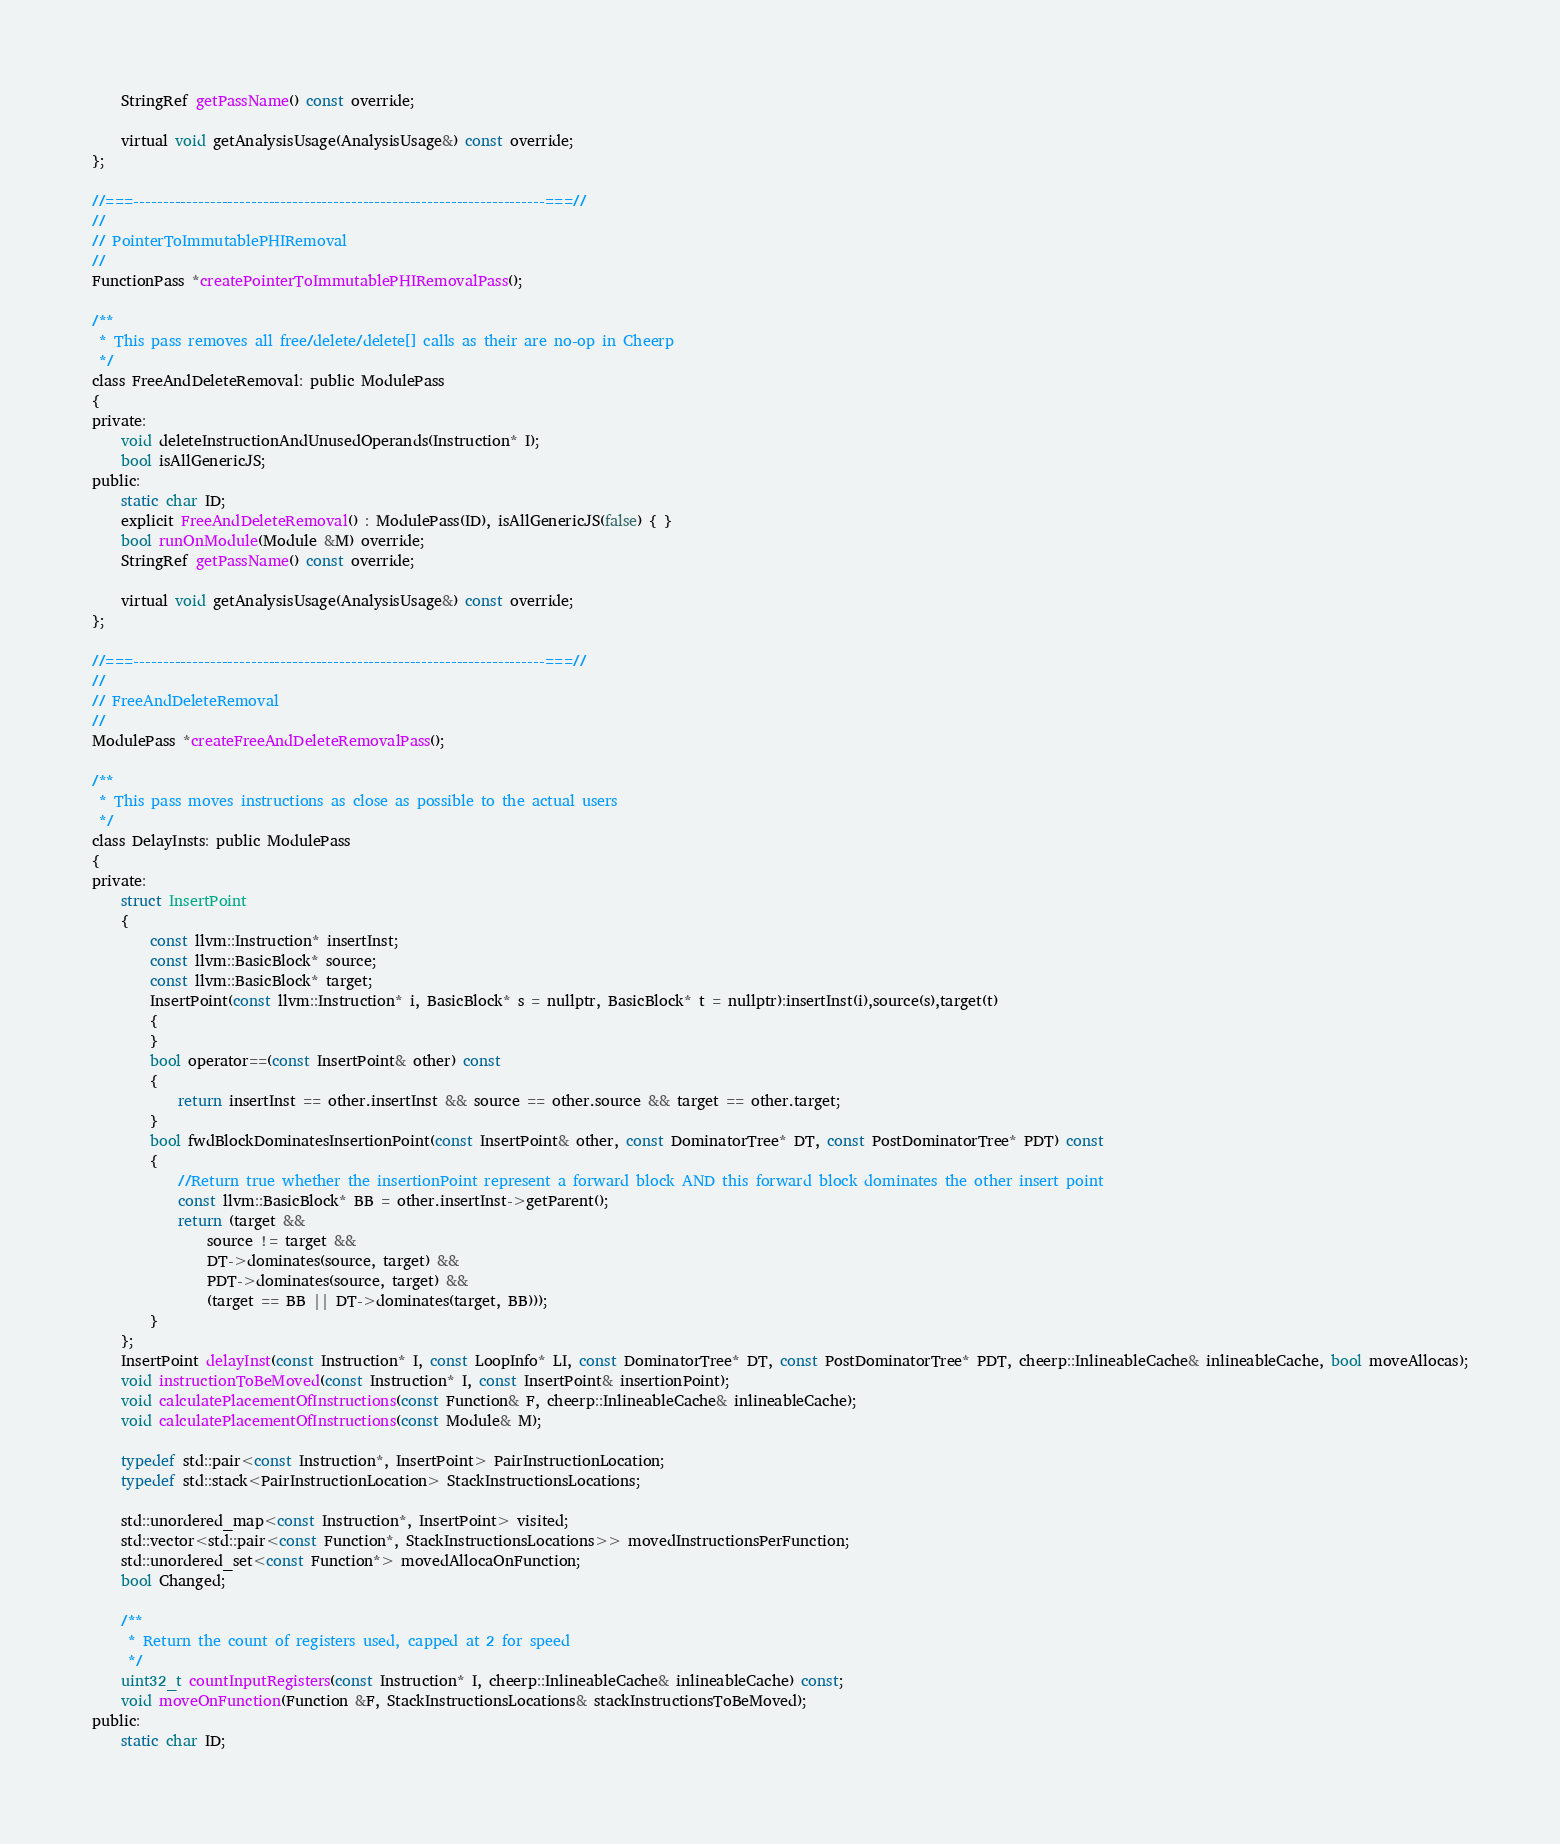Convert code to text. <code><loc_0><loc_0><loc_500><loc_500><_C_>	StringRef getPassName() const override;

	virtual void getAnalysisUsage(AnalysisUsage&) const override;
};

//===----------------------------------------------------------------------===//
//
// PointerToImmutablePHIRemoval
//
FunctionPass *createPointerToImmutablePHIRemovalPass();

/**
 * This pass removes all free/delete/delete[] calls as their are no-op in Cheerp
 */
class FreeAndDeleteRemoval: public ModulePass
{
private:
	void deleteInstructionAndUnusedOperands(Instruction* I);
	bool isAllGenericJS;
public:
	static char ID;
	explicit FreeAndDeleteRemoval() : ModulePass(ID), isAllGenericJS(false) { }
	bool runOnModule(Module &M) override;
	StringRef getPassName() const override;

	virtual void getAnalysisUsage(AnalysisUsage&) const override;
};

//===----------------------------------------------------------------------===//
//
// FreeAndDeleteRemoval
//
ModulePass *createFreeAndDeleteRemovalPass();

/**
 * This pass moves instructions as close as possible to the actual users
 */
class DelayInsts: public ModulePass
{
private:
	struct InsertPoint
	{
		const llvm::Instruction* insertInst;
		const llvm::BasicBlock* source;
		const llvm::BasicBlock* target;
		InsertPoint(const llvm::Instruction* i, BasicBlock* s = nullptr, BasicBlock* t = nullptr):insertInst(i),source(s),target(t)
		{
		}
		bool operator==(const InsertPoint& other) const
		{
			return insertInst == other.insertInst && source == other.source && target == other.target;
		}
		bool fwdBlockDominatesInsertionPoint(const InsertPoint& other, const DominatorTree* DT, const PostDominatorTree* PDT) const
		{
			//Return true whether the insertionPoint represent a forward block AND this forward block dominates the other insert point
			const llvm::BasicBlock* BB = other.insertInst->getParent();
			return (target &&
				source != target &&
				DT->dominates(source, target) &&
				PDT->dominates(source, target) &&
				(target == BB || DT->dominates(target, BB)));
		}
	};
	InsertPoint delayInst(const Instruction* I, const LoopInfo* LI, const DominatorTree* DT, const PostDominatorTree* PDT, cheerp::InlineableCache& inlineableCache, bool moveAllocas);
	void instructionToBeMoved(const Instruction* I, const InsertPoint& insertionPoint);
	void calculatePlacementOfInstructions(const Function& F, cheerp::InlineableCache& inlineableCache);
	void calculatePlacementOfInstructions(const Module& M);

	typedef std::pair<const Instruction*, InsertPoint> PairInstructionLocation;
	typedef std::stack<PairInstructionLocation> StackInstructionsLocations;

	std::unordered_map<const Instruction*, InsertPoint> visited;
	std::vector<std::pair<const Function*, StackInstructionsLocations>> movedInstructionsPerFunction;
	std::unordered_set<const Function*> movedAllocaOnFunction;
	bool Changed;

	/**
	 * Return the count of registers used, capped at 2 for speed
	 */
	uint32_t countInputRegisters(const Instruction* I, cheerp::InlineableCache& inlineableCache) const;
	void moveOnFunction(Function &F, StackInstructionsLocations& stackInstructionsToBeMoved);
public:
	static char ID;</code> 